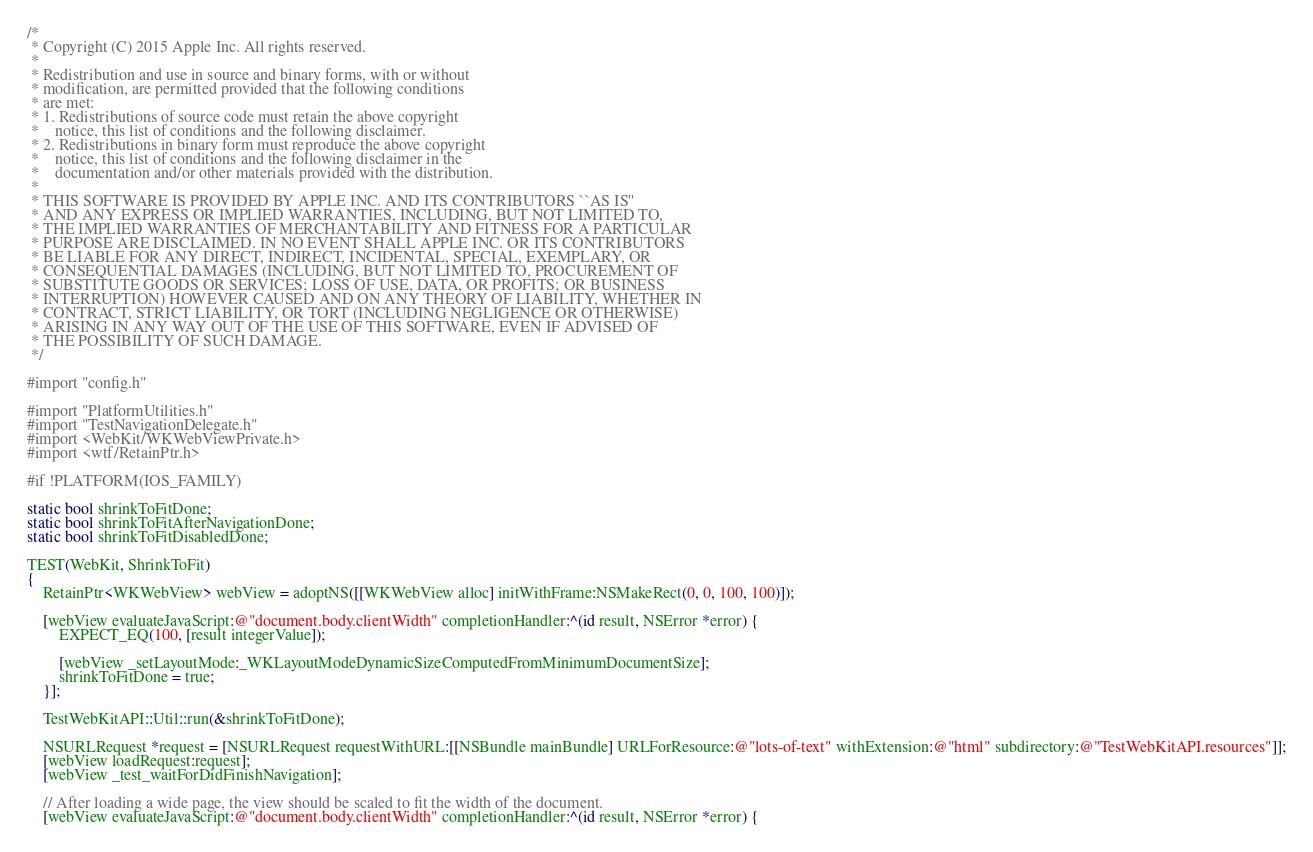Convert code to text. <code><loc_0><loc_0><loc_500><loc_500><_ObjectiveC_>/*
 * Copyright (C) 2015 Apple Inc. All rights reserved.
 *
 * Redistribution and use in source and binary forms, with or without
 * modification, are permitted provided that the following conditions
 * are met:
 * 1. Redistributions of source code must retain the above copyright
 *    notice, this list of conditions and the following disclaimer.
 * 2. Redistributions in binary form must reproduce the above copyright
 *    notice, this list of conditions and the following disclaimer in the
 *    documentation and/or other materials provided with the distribution.
 *
 * THIS SOFTWARE IS PROVIDED BY APPLE INC. AND ITS CONTRIBUTORS ``AS IS''
 * AND ANY EXPRESS OR IMPLIED WARRANTIES, INCLUDING, BUT NOT LIMITED TO,
 * THE IMPLIED WARRANTIES OF MERCHANTABILITY AND FITNESS FOR A PARTICULAR
 * PURPOSE ARE DISCLAIMED. IN NO EVENT SHALL APPLE INC. OR ITS CONTRIBUTORS
 * BE LIABLE FOR ANY DIRECT, INDIRECT, INCIDENTAL, SPECIAL, EXEMPLARY, OR
 * CONSEQUENTIAL DAMAGES (INCLUDING, BUT NOT LIMITED TO, PROCUREMENT OF
 * SUBSTITUTE GOODS OR SERVICES; LOSS OF USE, DATA, OR PROFITS; OR BUSINESS
 * INTERRUPTION) HOWEVER CAUSED AND ON ANY THEORY OF LIABILITY, WHETHER IN
 * CONTRACT, STRICT LIABILITY, OR TORT (INCLUDING NEGLIGENCE OR OTHERWISE)
 * ARISING IN ANY WAY OUT OF THE USE OF THIS SOFTWARE, EVEN IF ADVISED OF
 * THE POSSIBILITY OF SUCH DAMAGE.
 */

#import "config.h"

#import "PlatformUtilities.h"
#import "TestNavigationDelegate.h"
#import <WebKit/WKWebViewPrivate.h>
#import <wtf/RetainPtr.h>

#if !PLATFORM(IOS_FAMILY)

static bool shrinkToFitDone;
static bool shrinkToFitAfterNavigationDone;
static bool shrinkToFitDisabledDone;

TEST(WebKit, ShrinkToFit)
{
    RetainPtr<WKWebView> webView = adoptNS([[WKWebView alloc] initWithFrame:NSMakeRect(0, 0, 100, 100)]);

    [webView evaluateJavaScript:@"document.body.clientWidth" completionHandler:^(id result, NSError *error) {
        EXPECT_EQ(100, [result integerValue]);

        [webView _setLayoutMode:_WKLayoutModeDynamicSizeComputedFromMinimumDocumentSize];
        shrinkToFitDone = true;
    }];

    TestWebKitAPI::Util::run(&shrinkToFitDone);

    NSURLRequest *request = [NSURLRequest requestWithURL:[[NSBundle mainBundle] URLForResource:@"lots-of-text" withExtension:@"html" subdirectory:@"TestWebKitAPI.resources"]];
    [webView loadRequest:request];
    [webView _test_waitForDidFinishNavigation];

    // After loading a wide page, the view should be scaled to fit the width of the document.
    [webView evaluateJavaScript:@"document.body.clientWidth" completionHandler:^(id result, NSError *error) {</code> 